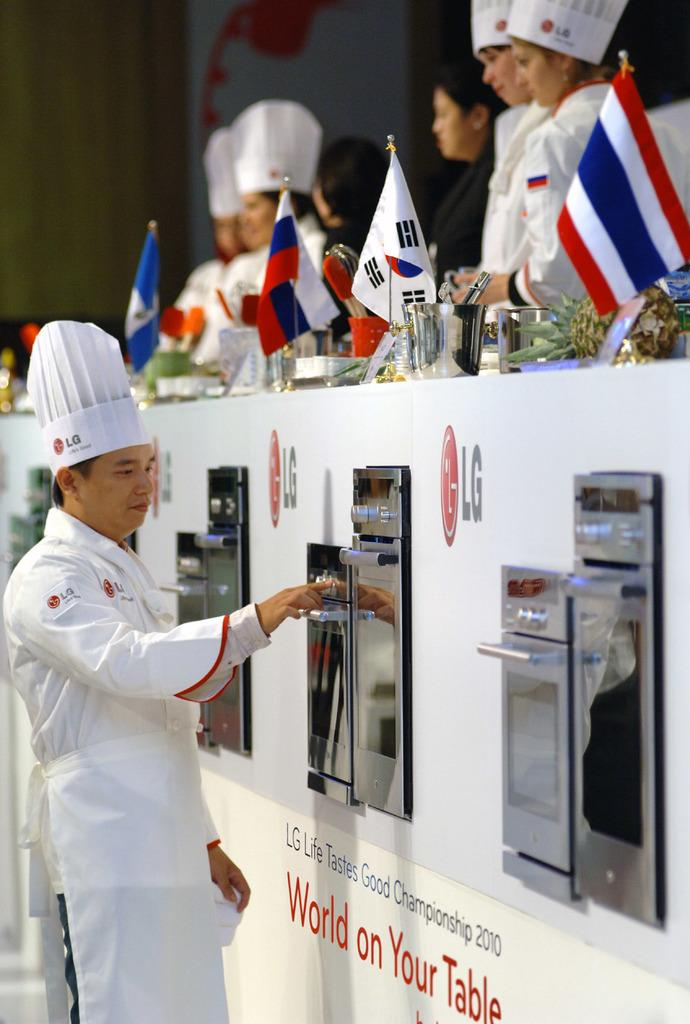<image>
Describe the image concisely. A competitor participates in a cooking competition sponsored by LG. 